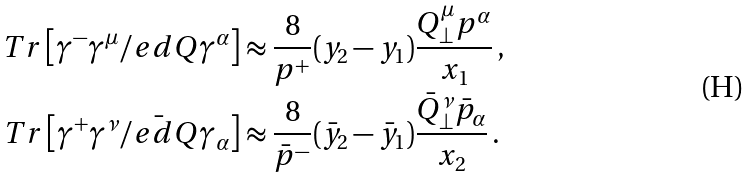Convert formula to latex. <formula><loc_0><loc_0><loc_500><loc_500>T r \left [ \gamma ^ { - } \gamma ^ { \mu } \slash e d { Q } \gamma ^ { \alpha } \right ] & \approx \frac { 8 } { p ^ { + } } ( y _ { 2 } - y _ { 1 } ) \frac { Q ^ { \mu } _ { \perp } p ^ { \alpha } } { x _ { 1 } } \, , \\ T r \left [ \gamma ^ { + } \gamma ^ { \nu } \bar { \slash e d { Q } } \gamma _ { \alpha } \right ] & \approx \frac { 8 } { \bar { p } ^ { - } } ( \bar { y } _ { 2 } - \bar { y } _ { 1 } ) \frac { \bar { Q } _ { \perp } ^ { \nu } \bar { p } _ { \alpha } } { x _ { 2 } } \, .</formula> 